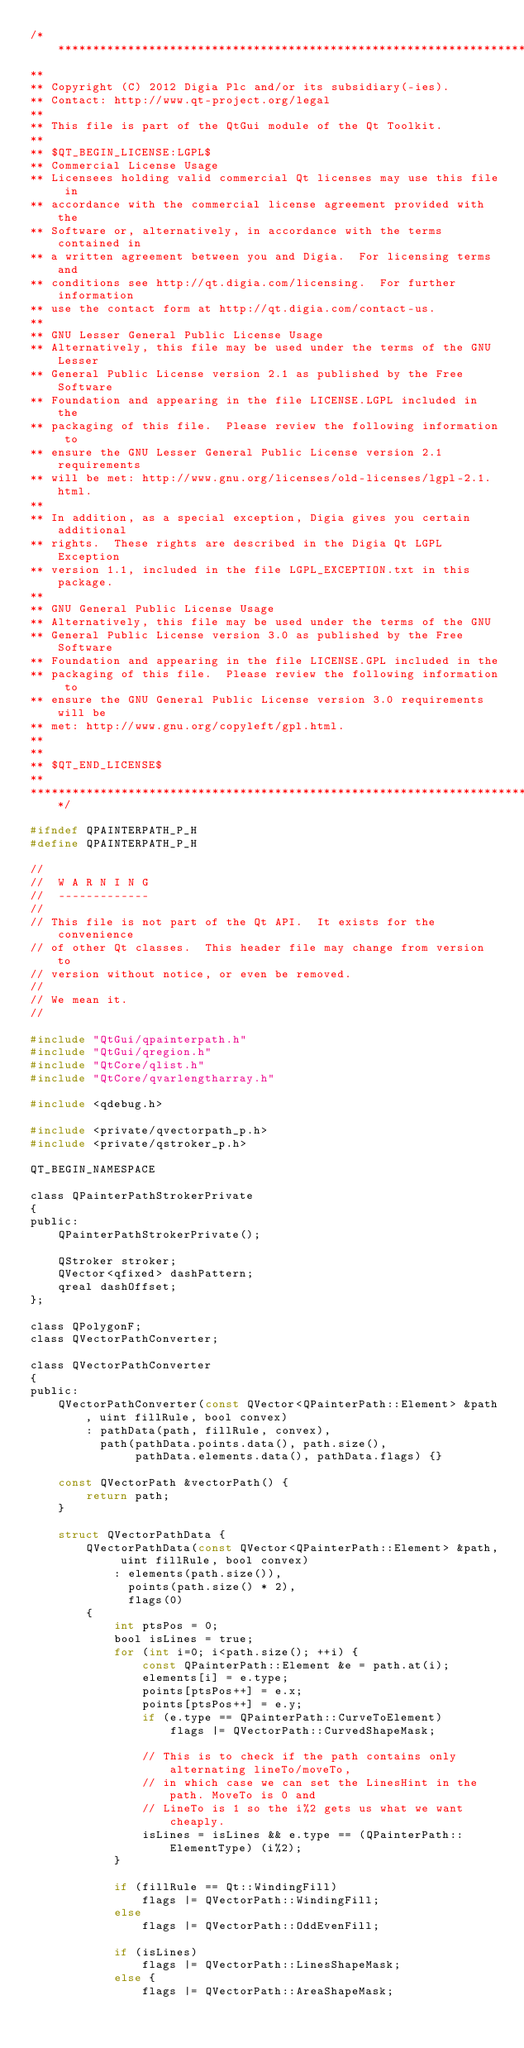Convert code to text. <code><loc_0><loc_0><loc_500><loc_500><_C_>/****************************************************************************
**
** Copyright (C) 2012 Digia Plc and/or its subsidiary(-ies).
** Contact: http://www.qt-project.org/legal
**
** This file is part of the QtGui module of the Qt Toolkit.
**
** $QT_BEGIN_LICENSE:LGPL$
** Commercial License Usage
** Licensees holding valid commercial Qt licenses may use this file in
** accordance with the commercial license agreement provided with the
** Software or, alternatively, in accordance with the terms contained in
** a written agreement between you and Digia.  For licensing terms and
** conditions see http://qt.digia.com/licensing.  For further information
** use the contact form at http://qt.digia.com/contact-us.
**
** GNU Lesser General Public License Usage
** Alternatively, this file may be used under the terms of the GNU Lesser
** General Public License version 2.1 as published by the Free Software
** Foundation and appearing in the file LICENSE.LGPL included in the
** packaging of this file.  Please review the following information to
** ensure the GNU Lesser General Public License version 2.1 requirements
** will be met: http://www.gnu.org/licenses/old-licenses/lgpl-2.1.html.
**
** In addition, as a special exception, Digia gives you certain additional
** rights.  These rights are described in the Digia Qt LGPL Exception
** version 1.1, included in the file LGPL_EXCEPTION.txt in this package.
**
** GNU General Public License Usage
** Alternatively, this file may be used under the terms of the GNU
** General Public License version 3.0 as published by the Free Software
** Foundation and appearing in the file LICENSE.GPL included in the
** packaging of this file.  Please review the following information to
** ensure the GNU General Public License version 3.0 requirements will be
** met: http://www.gnu.org/copyleft/gpl.html.
**
**
** $QT_END_LICENSE$
**
****************************************************************************/

#ifndef QPAINTERPATH_P_H
#define QPAINTERPATH_P_H

//
//  W A R N I N G
//  -------------
//
// This file is not part of the Qt API.  It exists for the convenience
// of other Qt classes.  This header file may change from version to
// version without notice, or even be removed.
//
// We mean it.
//

#include "QtGui/qpainterpath.h"
#include "QtGui/qregion.h"
#include "QtCore/qlist.h"
#include "QtCore/qvarlengtharray.h"

#include <qdebug.h>

#include <private/qvectorpath_p.h>
#include <private/qstroker_p.h>

QT_BEGIN_NAMESPACE

class QPainterPathStrokerPrivate
{
public:
    QPainterPathStrokerPrivate();

    QStroker stroker;
    QVector<qfixed> dashPattern;
    qreal dashOffset;
};

class QPolygonF;
class QVectorPathConverter;

class QVectorPathConverter
{
public:
    QVectorPathConverter(const QVector<QPainterPath::Element> &path, uint fillRule, bool convex)
        : pathData(path, fillRule, convex),
          path(pathData.points.data(), path.size(),
               pathData.elements.data(), pathData.flags) {}

    const QVectorPath &vectorPath() {
        return path;
    }

    struct QVectorPathData {
        QVectorPathData(const QVector<QPainterPath::Element> &path, uint fillRule, bool convex)
            : elements(path.size()),
              points(path.size() * 2),
              flags(0)
        {
            int ptsPos = 0;
            bool isLines = true;
            for (int i=0; i<path.size(); ++i) {
                const QPainterPath::Element &e = path.at(i);
                elements[i] = e.type;
                points[ptsPos++] = e.x;
                points[ptsPos++] = e.y;
                if (e.type == QPainterPath::CurveToElement)
                    flags |= QVectorPath::CurvedShapeMask;

                // This is to check if the path contains only alternating lineTo/moveTo,
                // in which case we can set the LinesHint in the path. MoveTo is 0 and
                // LineTo is 1 so the i%2 gets us what we want cheaply.
                isLines = isLines && e.type == (QPainterPath::ElementType) (i%2);
            }

            if (fillRule == Qt::WindingFill)
                flags |= QVectorPath::WindingFill;
            else
                flags |= QVectorPath::OddEvenFill;

            if (isLines)
                flags |= QVectorPath::LinesShapeMask;
            else {
                flags |= QVectorPath::AreaShapeMask;</code> 